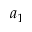Convert formula to latex. <formula><loc_0><loc_0><loc_500><loc_500>a _ { 1 }</formula> 